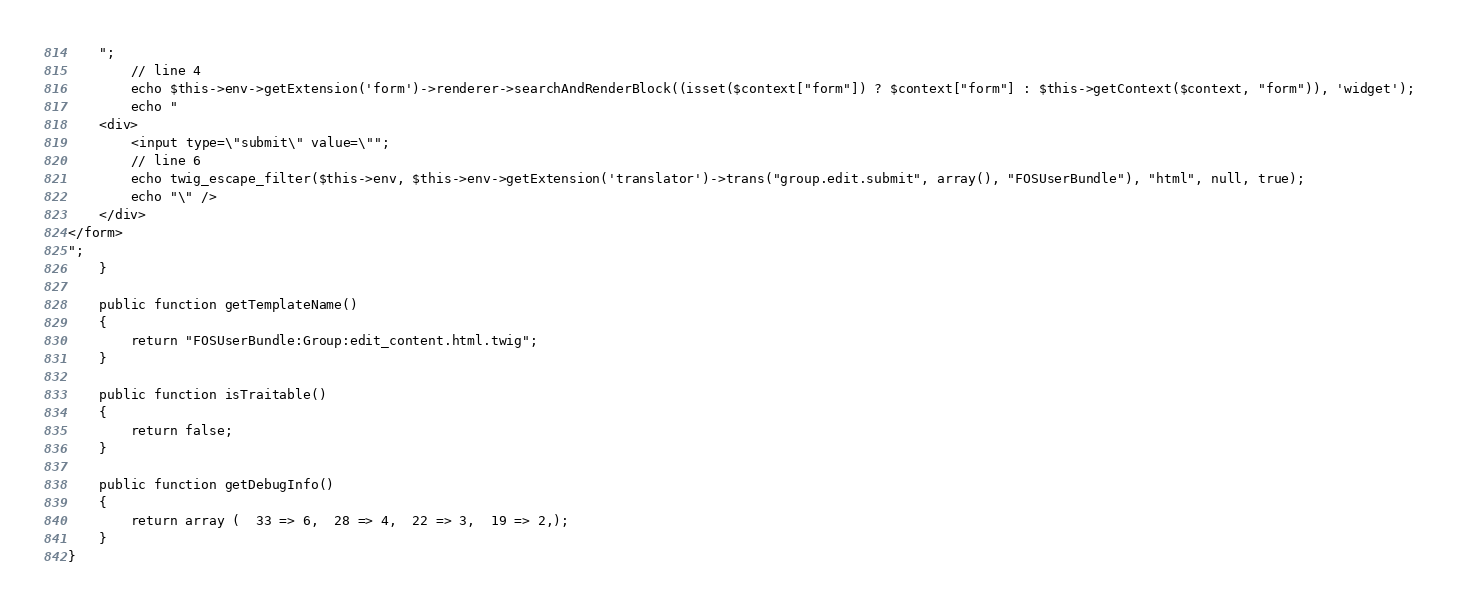<code> <loc_0><loc_0><loc_500><loc_500><_PHP_>    ";
        // line 4
        echo $this->env->getExtension('form')->renderer->searchAndRenderBlock((isset($context["form"]) ? $context["form"] : $this->getContext($context, "form")), 'widget');
        echo "
    <div>
        <input type=\"submit\" value=\"";
        // line 6
        echo twig_escape_filter($this->env, $this->env->getExtension('translator')->trans("group.edit.submit", array(), "FOSUserBundle"), "html", null, true);
        echo "\" />
    </div>
</form>
";
    }

    public function getTemplateName()
    {
        return "FOSUserBundle:Group:edit_content.html.twig";
    }

    public function isTraitable()
    {
        return false;
    }

    public function getDebugInfo()
    {
        return array (  33 => 6,  28 => 4,  22 => 3,  19 => 2,);
    }
}
</code> 